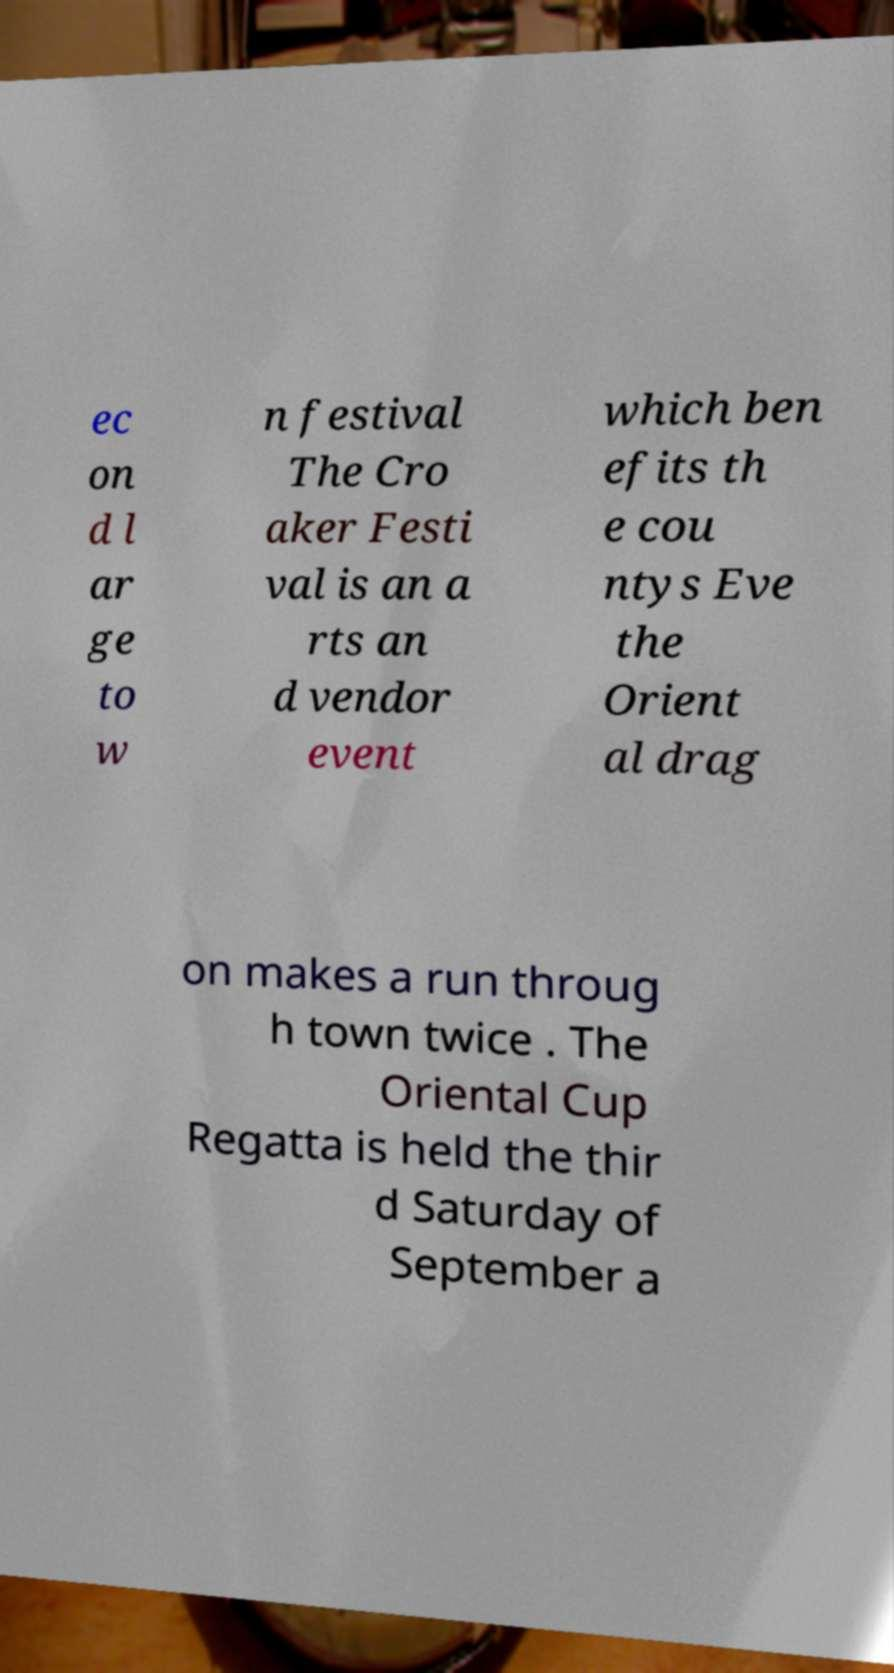Please identify and transcribe the text found in this image. ec on d l ar ge to w n festival The Cro aker Festi val is an a rts an d vendor event which ben efits th e cou ntys Eve the Orient al drag on makes a run throug h town twice . The Oriental Cup Regatta is held the thir d Saturday of September a 